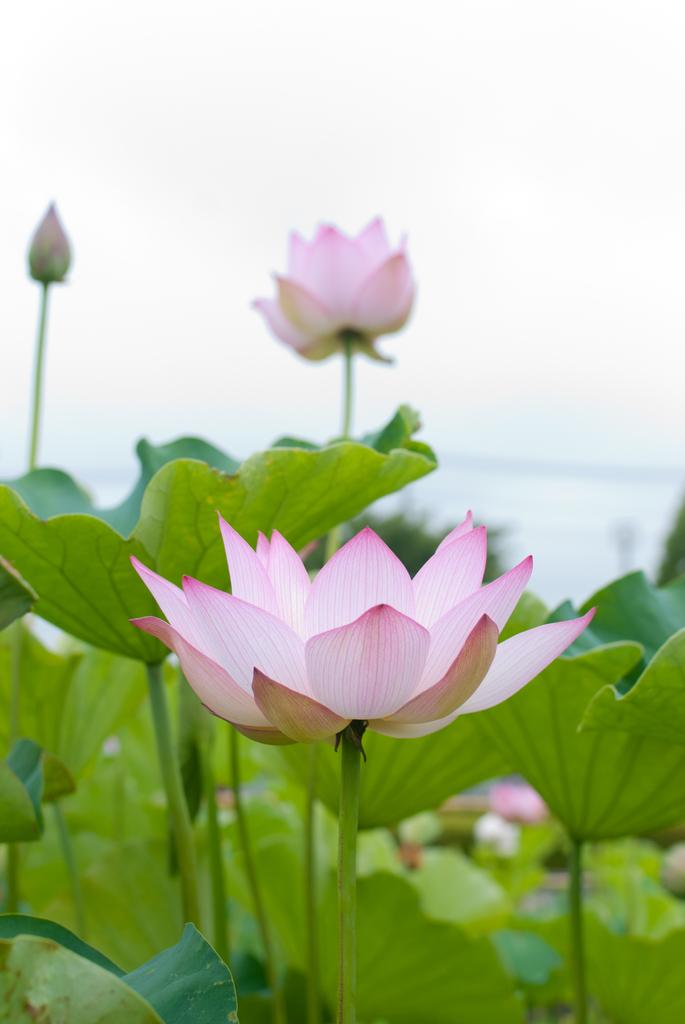What type of plants are in the image? The plants in the image have lotus flowers. What is the main feature of these plants? The main feature of these plants is the lotus flowers. Can you describe the background of the image? The background of the image is blurred. How does the wind affect the hair of the plants in the image? There is no hair present on the plants in the image, as they are plants with lotus flowers. 